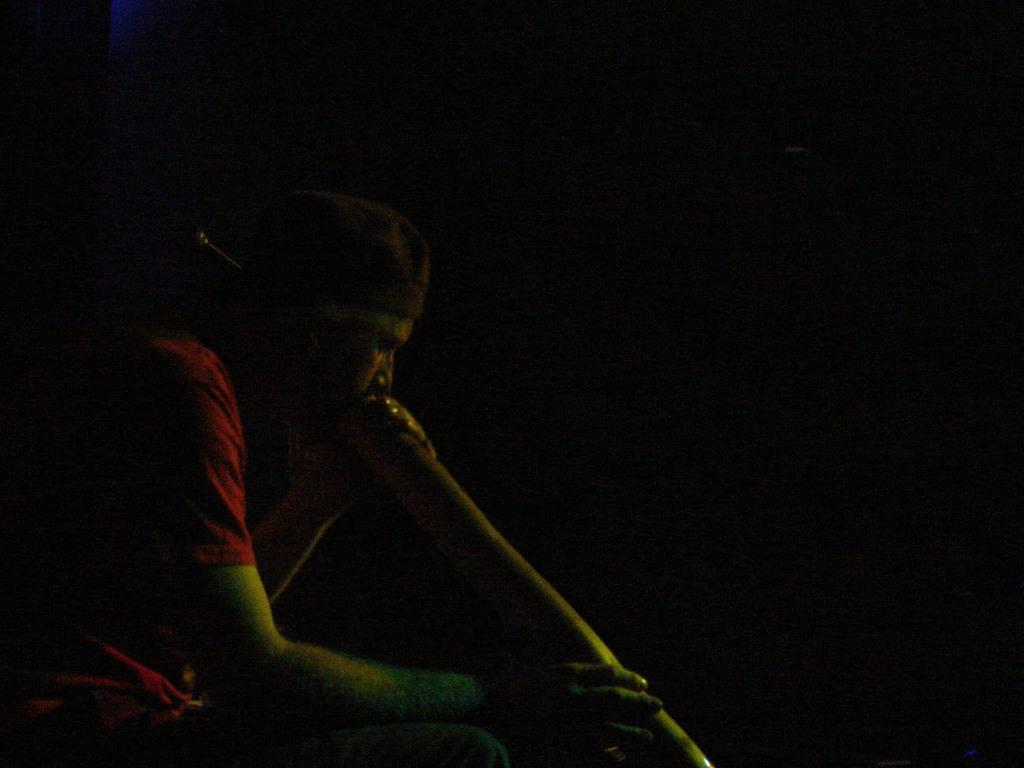Who is present in the image? There is a man in the image. What is the man wearing? The man is wearing a red t-shirt. What is the man holding in the image? The man is holding a wooden stick. What is the color of the background in the image? The background of the image is black. How many horses can be seen in the image? There are no horses present in the image. What type of duck is swimming in the background of the image? There is no duck present in the image; the background is black. 